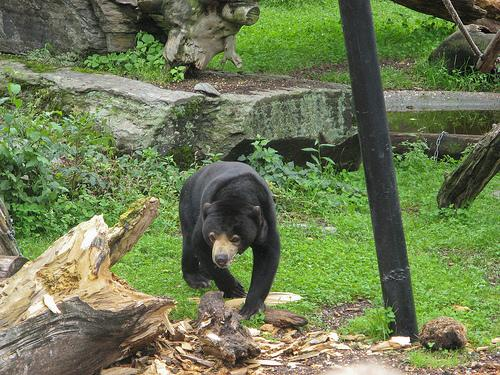Describe any water-related features in the image. There is stagnant water with reflection, which appears to be green in color. Describe any visible body parts of the bear and their characteristics. The bear has a head with two small ears, eyes, a white snout, a dark brown nose, black fur, and legs with black paws. Find an object related to the bear and describe its appearance. The white snout of the bear is visible, which has dark brown nose and ears. Identify the primary object in the image and describe its color. The primary object is a black bear walking on the ground. What type of object is near the wood chips in the image? A black metal pole is near the wood chips. What is the bear doing in the image? The black bear is walking on the ground. Select a large item next to the bear in the image and describe it. There is a large piece of wood or a dead tree trunk next to the bear. Choose a detail related to vegetation in the image and describe it. There are green and leafy bushes behind the bear. Identify the color and type of surface the bear is walking on. The bear is walking on green grass. Examine the setting of the image and describe the environment. The image is set outdoors during the day time, with green grass, leafy bushes, a grey stone ledge, and tall green grasses in the background. 